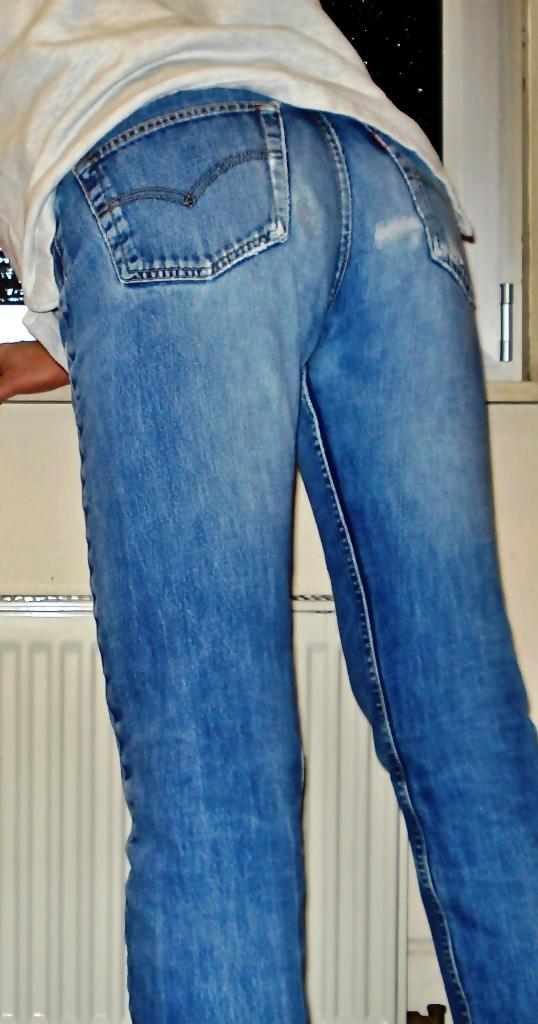Where was the image taken? The image was taken indoors. What can be seen in the background of the image? There is a window and a kitchen platform with a cupboard in the background of the image. Who or what is in the middle of the image? A person is standing in the middle of the image. What type of clouds can be seen through the window in the image? There are no clouds visible in the image, as it was taken indoors and does not show any outdoor elements. 